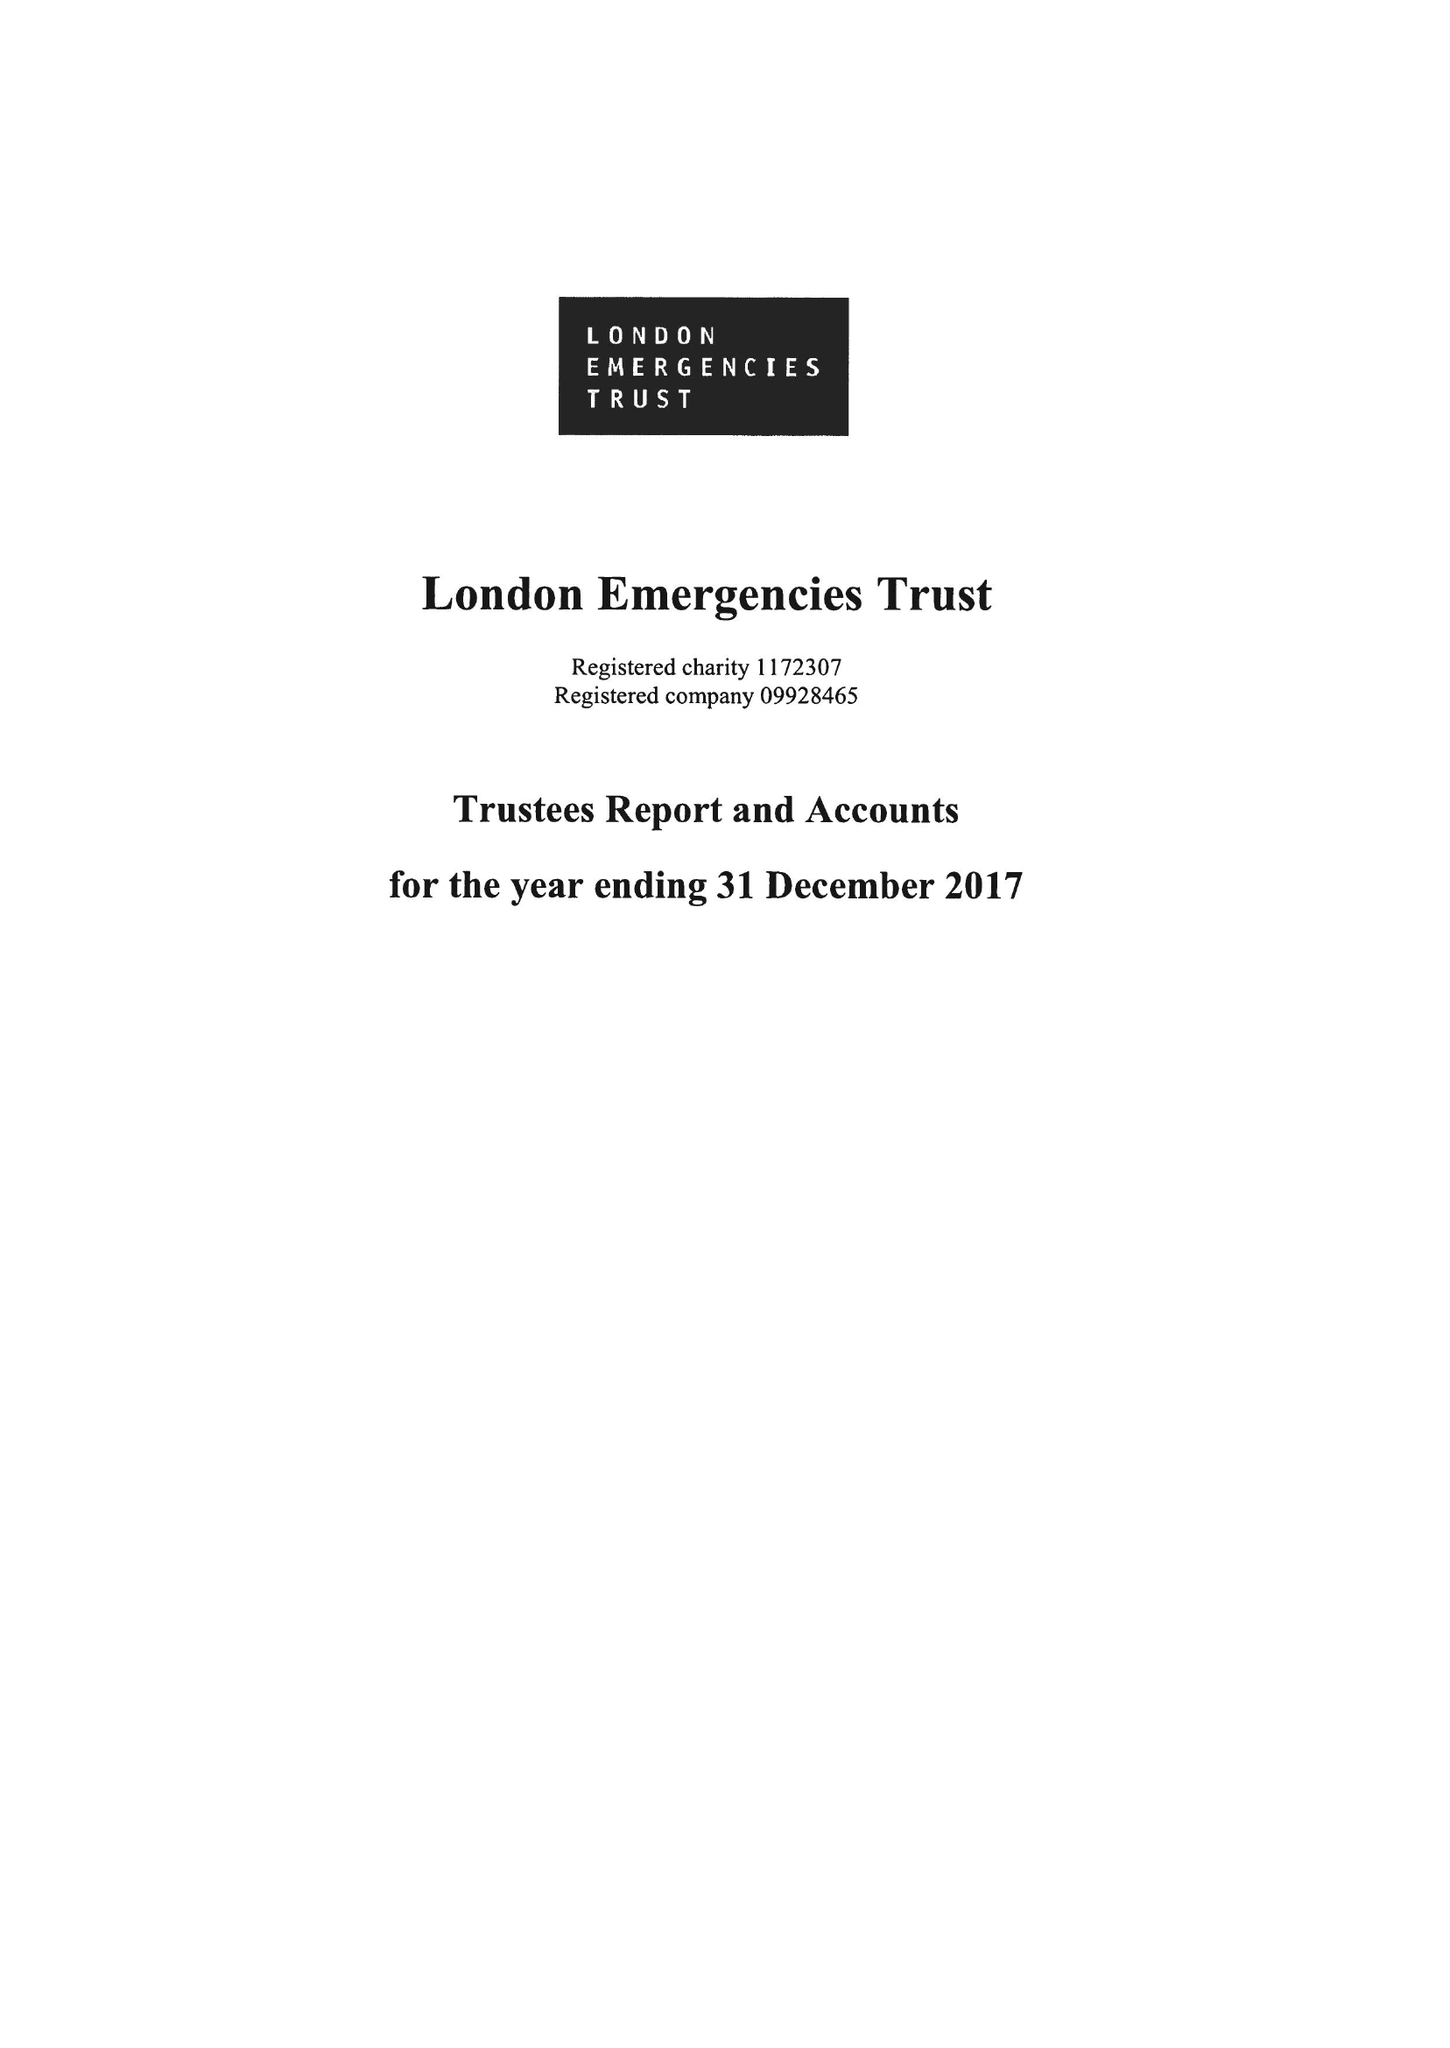What is the value for the address__postcode?
Answer the question using a single word or phrase. E1 6LS 